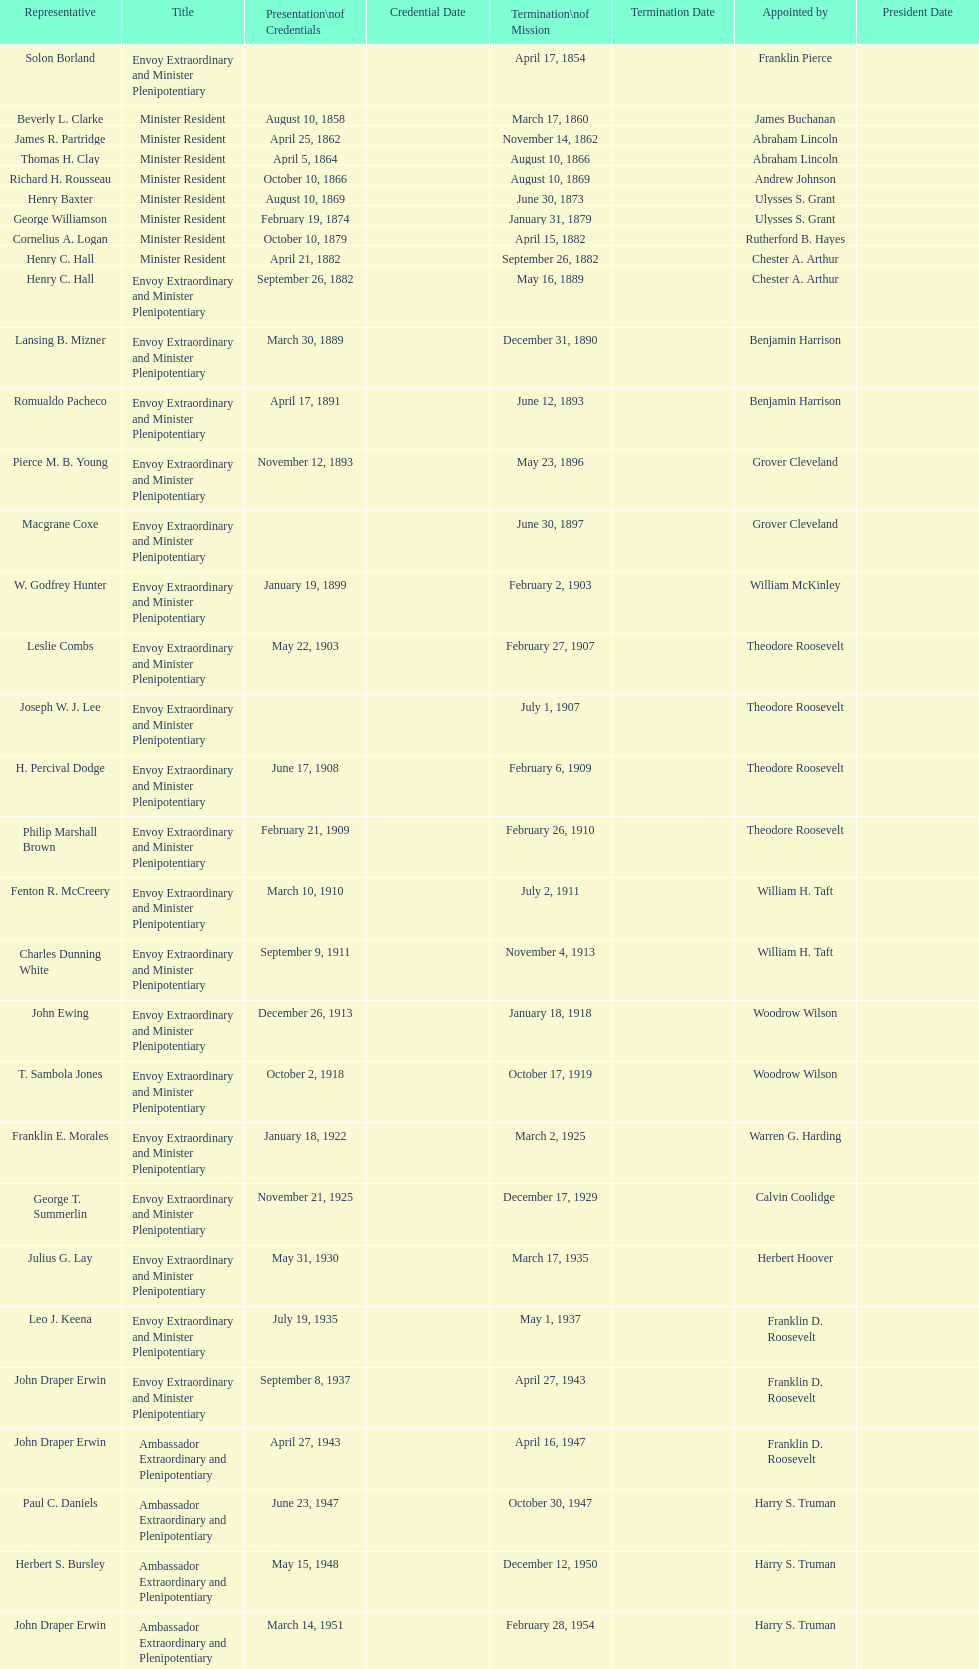Is solon borland a delegate? Yes. 